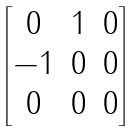Convert formula to latex. <formula><loc_0><loc_0><loc_500><loc_500>\begin{bmatrix} 0 & 1 & 0 \\ - 1 & 0 & 0 \\ 0 & 0 & 0 \end{bmatrix}</formula> 